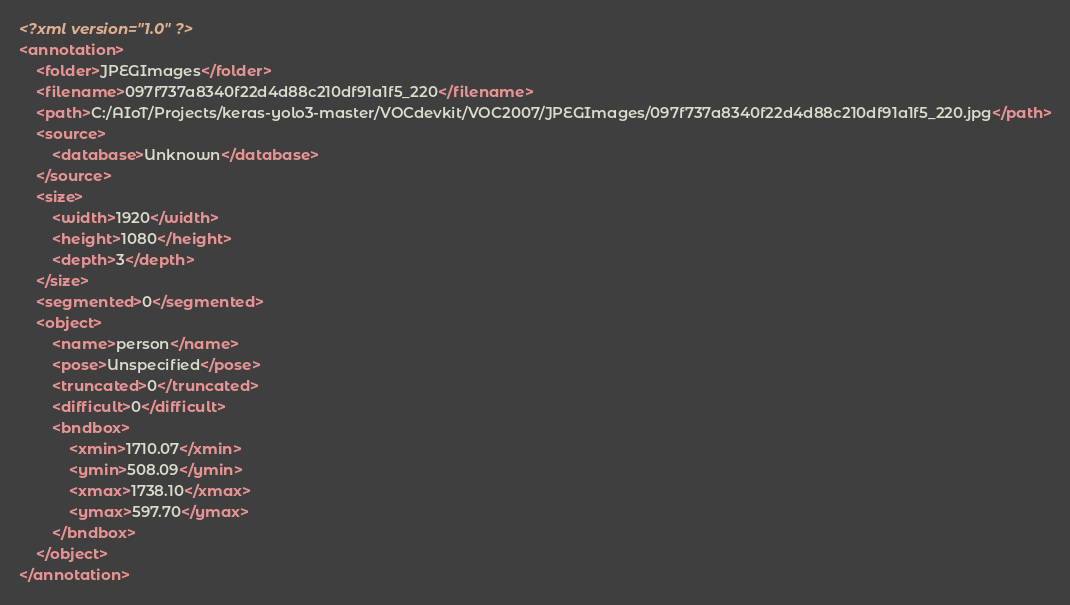<code> <loc_0><loc_0><loc_500><loc_500><_XML_><?xml version="1.0" ?>
<annotation>
	<folder>JPEGImages</folder>
	<filename>097f737a8340f22d4d88c210df91a1f5_220</filename>
	<path>C:/AIoT/Projects/keras-yolo3-master/VOCdevkit/VOC2007/JPEGImages/097f737a8340f22d4d88c210df91a1f5_220.jpg</path>
	<source>
		<database>Unknown</database>
	</source>
	<size>
		<width>1920</width>
		<height>1080</height>
		<depth>3</depth>
	</size>
	<segmented>0</segmented>
	<object>
		<name>person</name>
		<pose>Unspecified</pose>
		<truncated>0</truncated>
		<difficult>0</difficult>
		<bndbox>
			<xmin>1710.07</xmin>
			<ymin>508.09</ymin>
			<xmax>1738.10</xmax>
			<ymax>597.70</ymax>
		</bndbox>
	</object>
</annotation>
</code> 